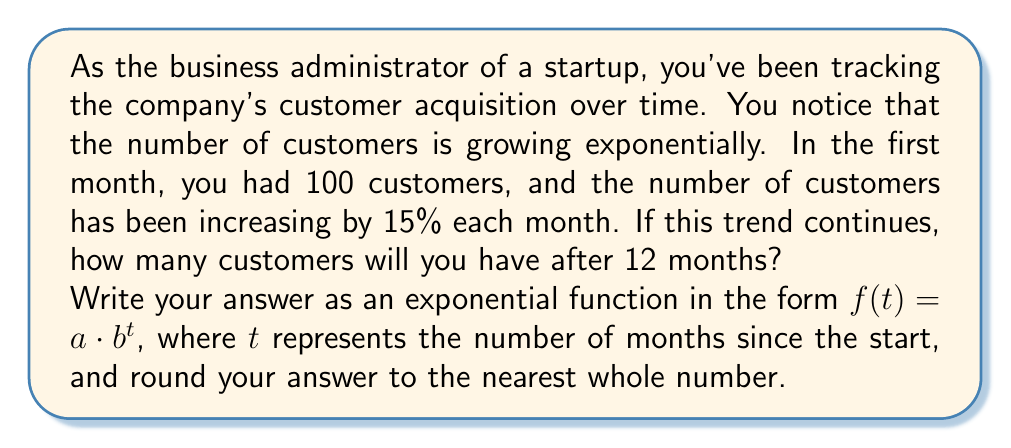Can you solve this math problem? To solve this problem, we need to use the exponential growth formula:

$f(t) = a \cdot b^t$

Where:
$f(t)$ is the number of customers after $t$ months
$a$ is the initial number of customers
$b$ is the growth factor (1 + growth rate)
$t$ is the number of months

1. Initial number of customers, $a = 100$

2. Growth rate is 15% per month, so the growth factor $b = 1 + 0.15 = 1.15$

3. We want to find the number of customers after 12 months, so $t = 12$

Now, let's plug these values into our exponential function:

$f(12) = 100 \cdot (1.15)^{12}$

To calculate this:

$f(12) = 100 \cdot (1.15)^{12}$
$f(12) = 100 \cdot 5.4736$
$f(12) = 547.36$

Rounding to the nearest whole number:

$f(12) \approx 547$ customers

Therefore, our exponential function for customer growth is:

$f(t) = 100 \cdot (1.15)^t$

Where $t$ is the number of months since the start.
Answer: $f(t) = 100 \cdot (1.15)^t$ 